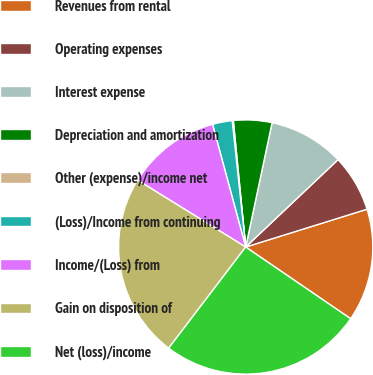Convert chart. <chart><loc_0><loc_0><loc_500><loc_500><pie_chart><fcel>Revenues from rental<fcel>Operating expenses<fcel>Interest expense<fcel>Depreciation and amortization<fcel>Other (expense)/income net<fcel>(Loss)/Income from continuing<fcel>Income/(Loss) from<fcel>Gain on disposition of<fcel>Net (loss)/income<nl><fcel>14.35%<fcel>7.25%<fcel>9.61%<fcel>4.88%<fcel>0.14%<fcel>2.51%<fcel>11.98%<fcel>23.46%<fcel>25.82%<nl></chart> 